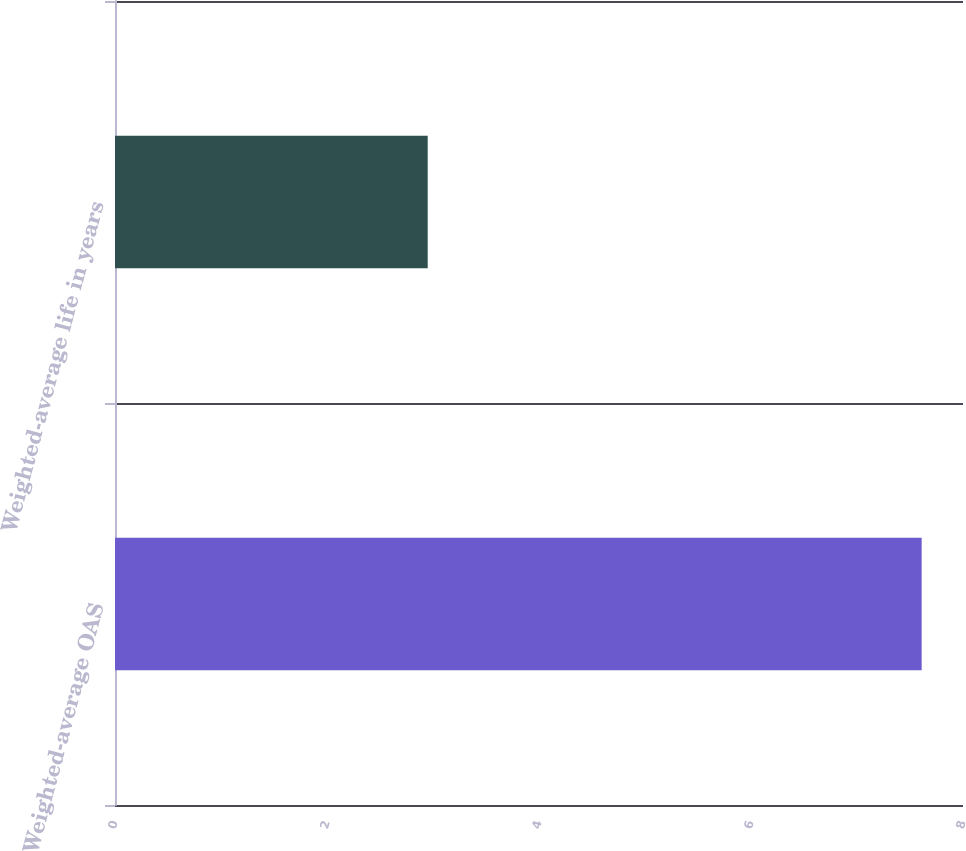<chart> <loc_0><loc_0><loc_500><loc_500><bar_chart><fcel>Weighted-average OAS<fcel>Weighted-average life in years<nl><fcel>7.61<fcel>2.95<nl></chart> 